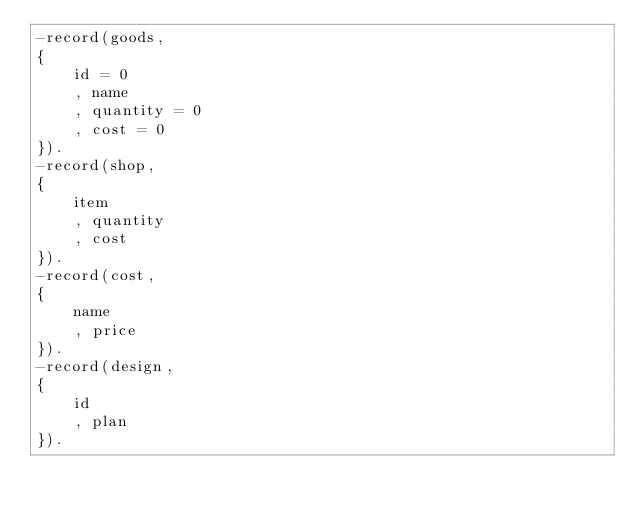<code> <loc_0><loc_0><loc_500><loc_500><_Erlang_>-record(goods,
{
    id = 0
    , name
    , quantity = 0
    , cost = 0
}).
-record(shop,
{
    item
    , quantity
    , cost
}).
-record(cost,
{
    name
    , price
}).
-record(design,
{
    id
    , plan
}).




</code> 